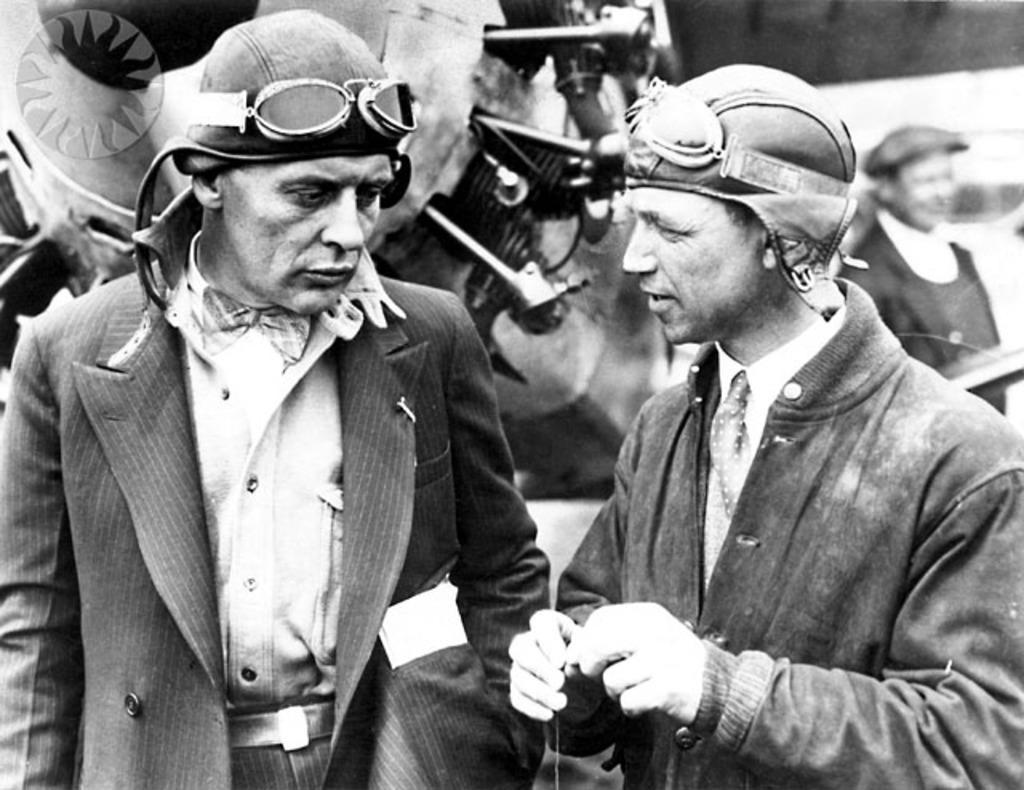Describe this image in one or two sentences. In this image I can see two men in the front and I can see both of them are wearing caps and on their caps I can see goggles. On the right side of this image I can see one more person. In the background I can an object. I can also see this image is black and white in colour. 